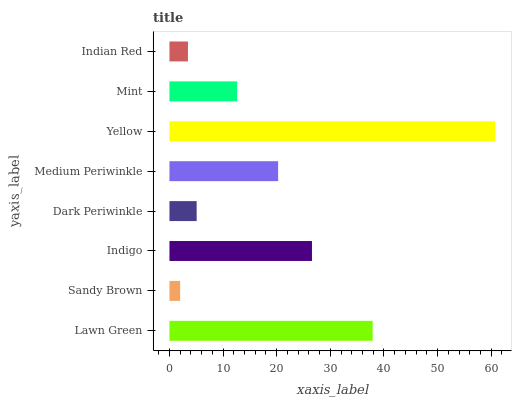Is Sandy Brown the minimum?
Answer yes or no. Yes. Is Yellow the maximum?
Answer yes or no. Yes. Is Indigo the minimum?
Answer yes or no. No. Is Indigo the maximum?
Answer yes or no. No. Is Indigo greater than Sandy Brown?
Answer yes or no. Yes. Is Sandy Brown less than Indigo?
Answer yes or no. Yes. Is Sandy Brown greater than Indigo?
Answer yes or no. No. Is Indigo less than Sandy Brown?
Answer yes or no. No. Is Medium Periwinkle the high median?
Answer yes or no. Yes. Is Mint the low median?
Answer yes or no. Yes. Is Dark Periwinkle the high median?
Answer yes or no. No. Is Medium Periwinkle the low median?
Answer yes or no. No. 